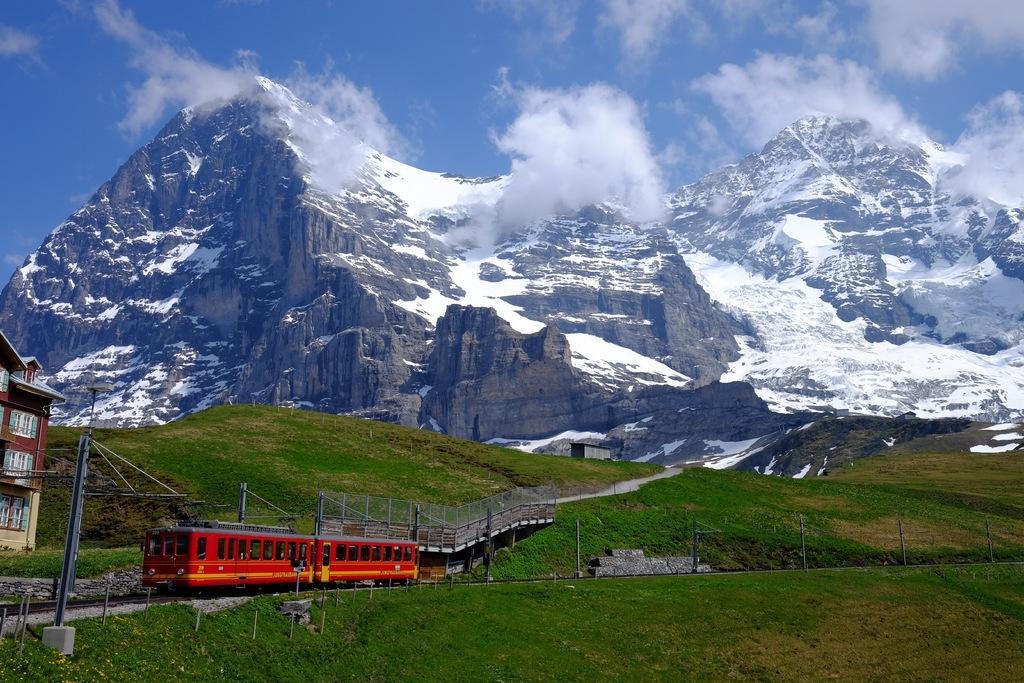Please provide a concise description of this image. In this image we can see the mountains, hill, building, fence, path, poles, wires and also the sky with the clouds. We can also see a train passing on the railway track. 